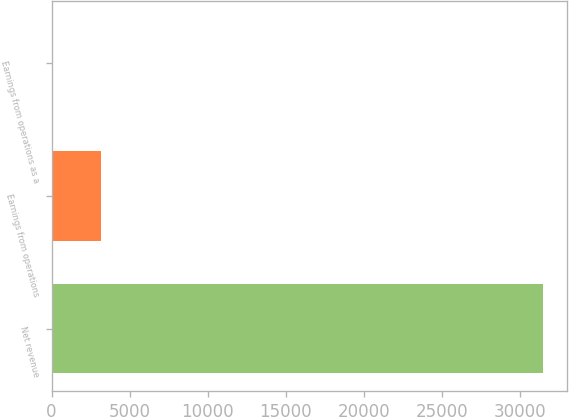<chart> <loc_0><loc_0><loc_500><loc_500><bar_chart><fcel>Net revenue<fcel>Earnings from operations<fcel>Earnings from operations as a<nl><fcel>31469<fcel>3149.96<fcel>3.4<nl></chart> 